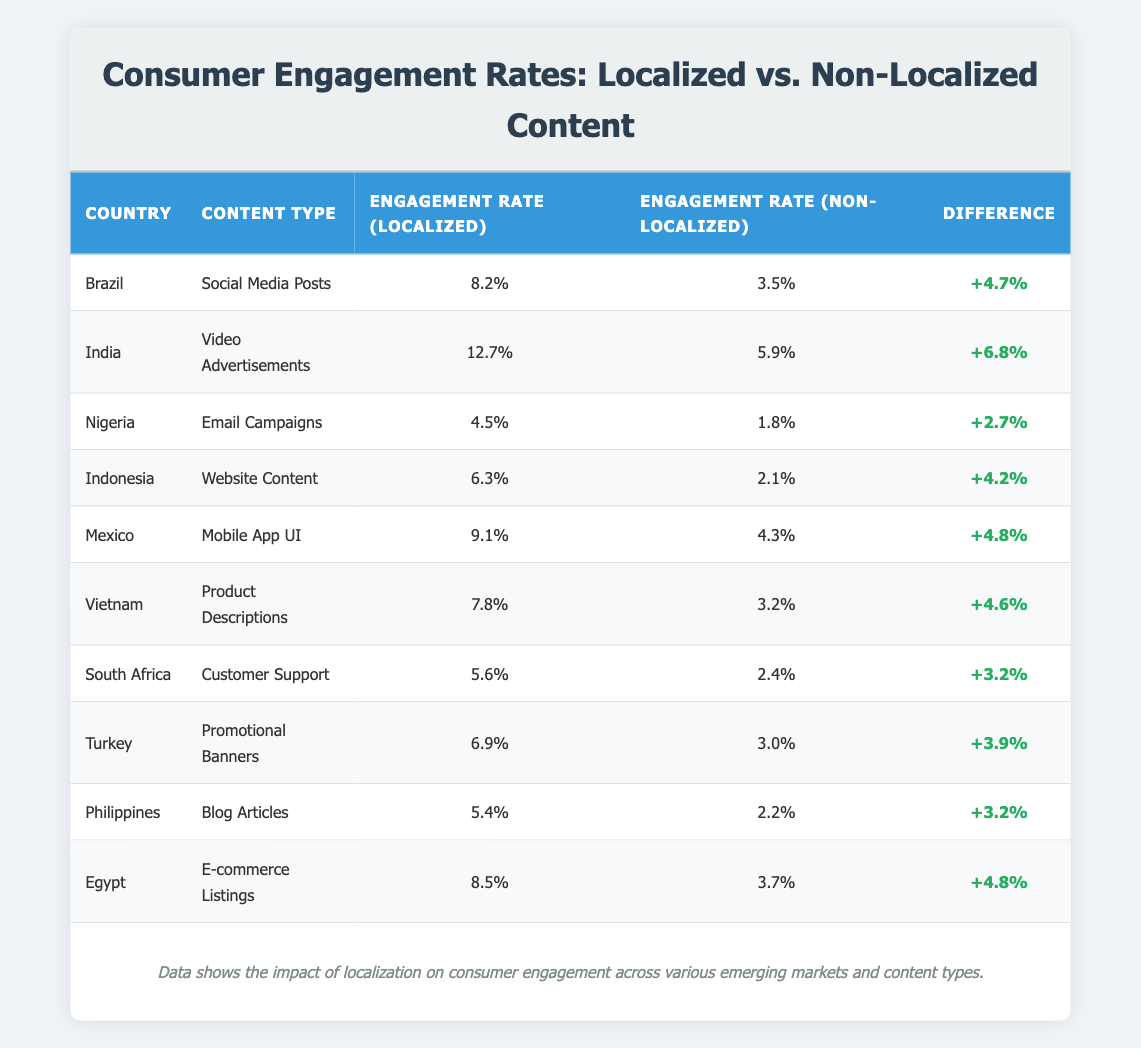What is the engagement rate for localized video advertisements in India? The table lists India in the row for video advertisements under the "Engagement Rate (Localized)" column, which shows 12.7%.
Answer: 12.7% Which country shows the highest difference in engagement rates between localized and non-localized content? By comparing the "Difference" column values, India has the highest difference of +6.8% over all the listed countries.
Answer: India Is the engagement rate for localized customer support in South Africa higher than in Turkey? The localized engagement rate for South Africa is 5.6%, while for Turkey, it is 6.9%. Since 5.6% is less than 6.9%, the statement is false.
Answer: No What is the average engagement rate for localized content across the listed countries? The localized engagement rates for each country are: 8.2%, 12.7%, 4.5%, 6.3%, 9.1%, 7.8%, 5.6%, 6.9%, 5.4%, and 8.5%. Adding these together gives 64.6%, and dividing by 10 results in an average of 6.46%.
Answer: 6.46% How many countries have an engagement rate difference of more than 4%? The differences for the listed countries are: +4.7%, +6.8%, +2.7%, +4.2%, +4.8%, +4.6%, +3.2%, +3.9%, +3.2%, and +4.8%. Counting those greater than 4% gives a total of six countries.
Answer: Six Which content type has the lowest engagement rate for localized content? By reviewing the "Engagement Rate (Localized)" column, Nigeria’s email campaigns show the lowest localized engagement rate at 4.5%.
Answer: Email Campaigns Is the engagement rate for non-localized e-commerce listings in Egypt lower than that for localized social media posts in Brazil? The non-localized engagement rate for e-commerce listings in Egypt is 3.7%, while the localized rate for social media posts in Brazil is 8.2%. Since 3.7% is less than 8.2%, the statement is true.
Answer: Yes Which country has a better localized engagement rate: Vietnam for product descriptions or Mexico for mobile app UI? Vietnam's localized engagement rate is 7.8% for product descriptions, while Mexico's rate is 9.1% for mobile app UI. Comparing these figures reveals that 9.1% (Mexico) is greater than 7.8% (Vietnam).
Answer: Mexico What is the total engagement rate difference for email campaigns across Nigeria? The engagement differences for the email campaigns in Nigeria is +2.7%. Thus, there is no other data for this content type in the table to sum with.
Answer: 2.7% 